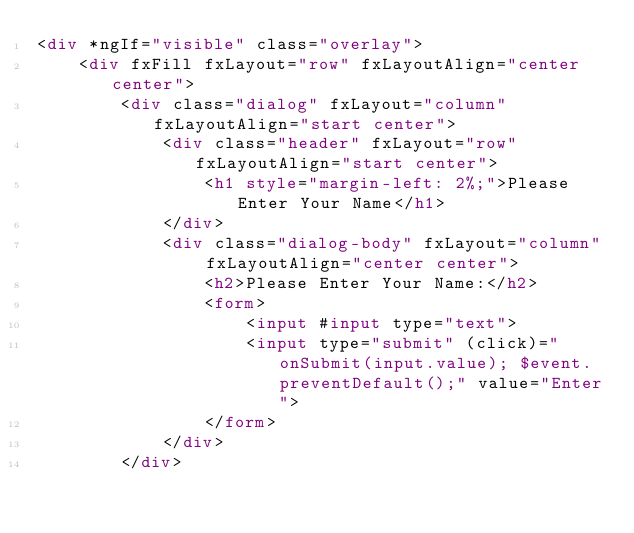Convert code to text. <code><loc_0><loc_0><loc_500><loc_500><_HTML_><div *ngIf="visible" class="overlay">
    <div fxFill fxLayout="row" fxLayoutAlign="center center">
        <div class="dialog" fxLayout="column" fxLayoutAlign="start center">
            <div class="header" fxLayout="row" fxLayoutAlign="start center">
                <h1 style="margin-left: 2%;">Please Enter Your Name</h1>
            </div>
            <div class="dialog-body" fxLayout="column" fxLayoutAlign="center center">
                <h2>Please Enter Your Name:</h2>
                <form>
                    <input #input type="text">
                    <input type="submit" (click)="onSubmit(input.value); $event.preventDefault();" value="Enter">
                </form>
            </div>
        </div></code> 